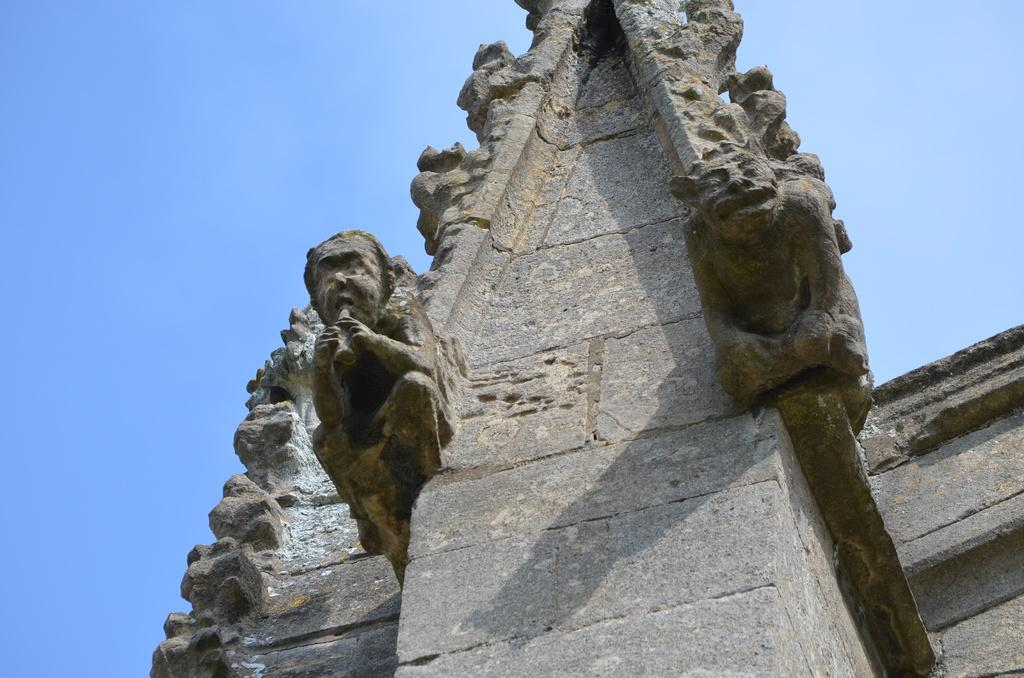What type of art is present in the image? There are sculptures in the image. What is the backdrop for the sculptures in the image? There is a wall in the image. What can be seen in the distance behind the wall? The sky is visible in the background of the image. What type of iron is used to create the boundary in the image? There is no boundary or iron present in the image; it features sculptures and a wall. 